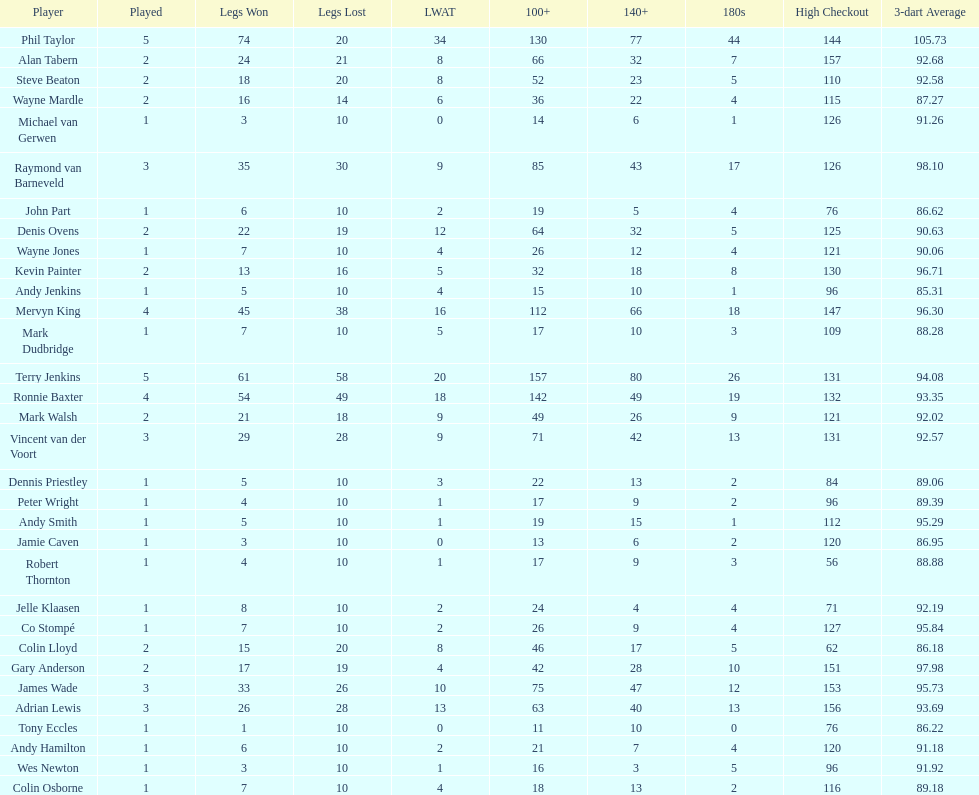Mark walsh's average is above/below 93? Below. 